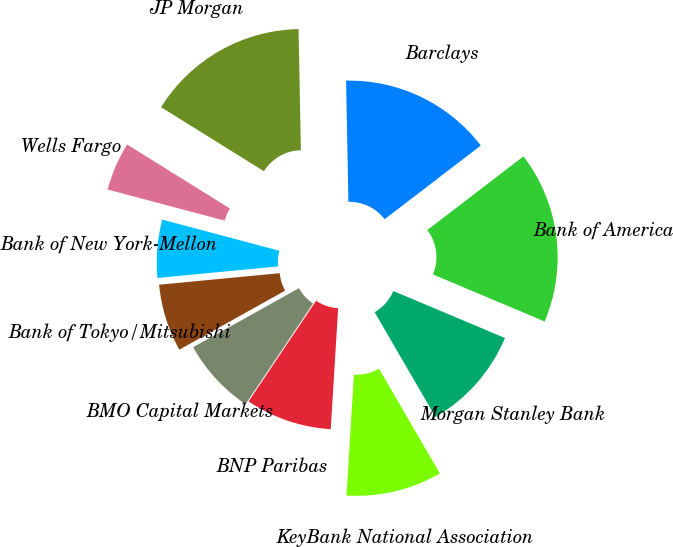Convert chart. <chart><loc_0><loc_0><loc_500><loc_500><pie_chart><fcel>Bank of America<fcel>Barclays<fcel>JP Morgan<fcel>Wells Fargo<fcel>Bank of New York-Mellon<fcel>Bank of Tokyo/Mitsubishi<fcel>BMO Capital Markets<fcel>BNP Paribas<fcel>KeyBank National Association<fcel>Morgan Stanley Bank<nl><fcel>16.75%<fcel>14.9%<fcel>15.83%<fcel>4.73%<fcel>5.65%<fcel>6.58%<fcel>7.5%<fcel>8.43%<fcel>9.35%<fcel>10.28%<nl></chart> 